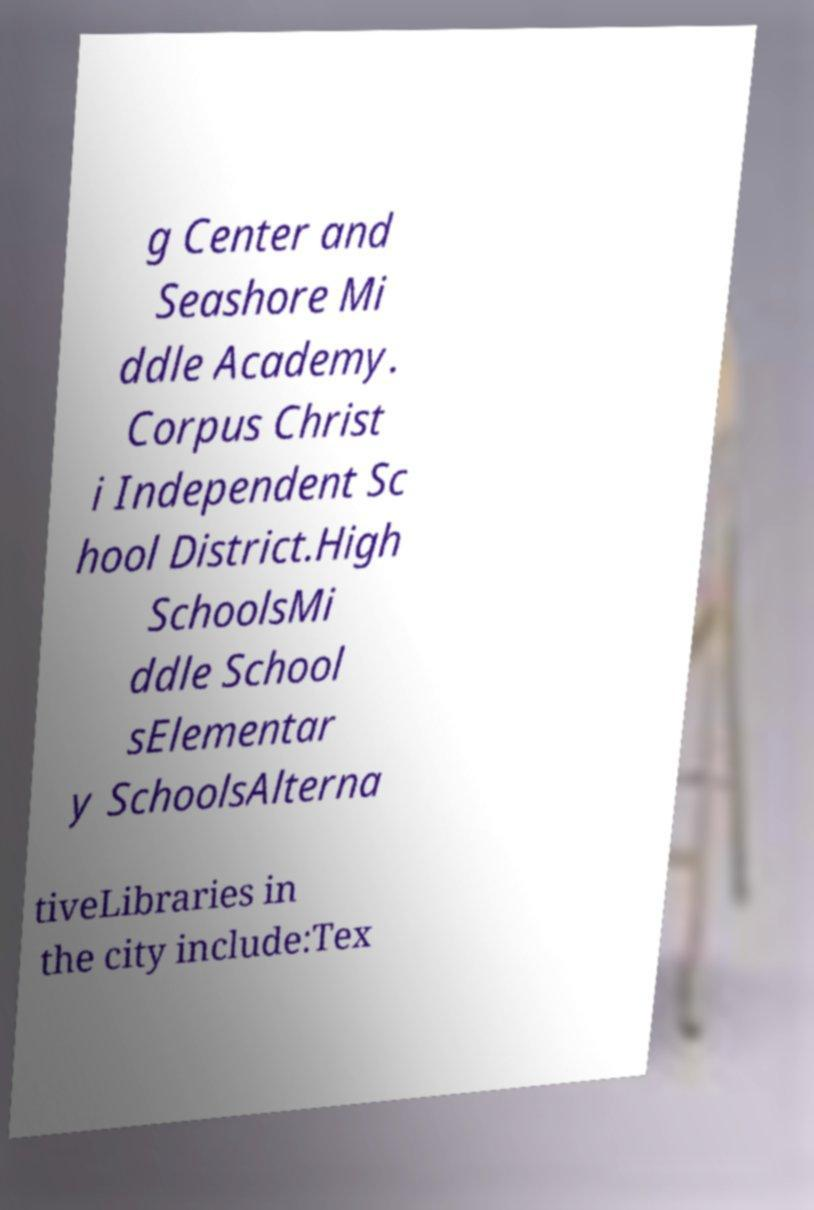Please identify and transcribe the text found in this image. g Center and Seashore Mi ddle Academy. Corpus Christ i Independent Sc hool District.High SchoolsMi ddle School sElementar y SchoolsAlterna tiveLibraries in the city include:Tex 